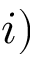Convert formula to latex. <formula><loc_0><loc_0><loc_500><loc_500>i )</formula> 